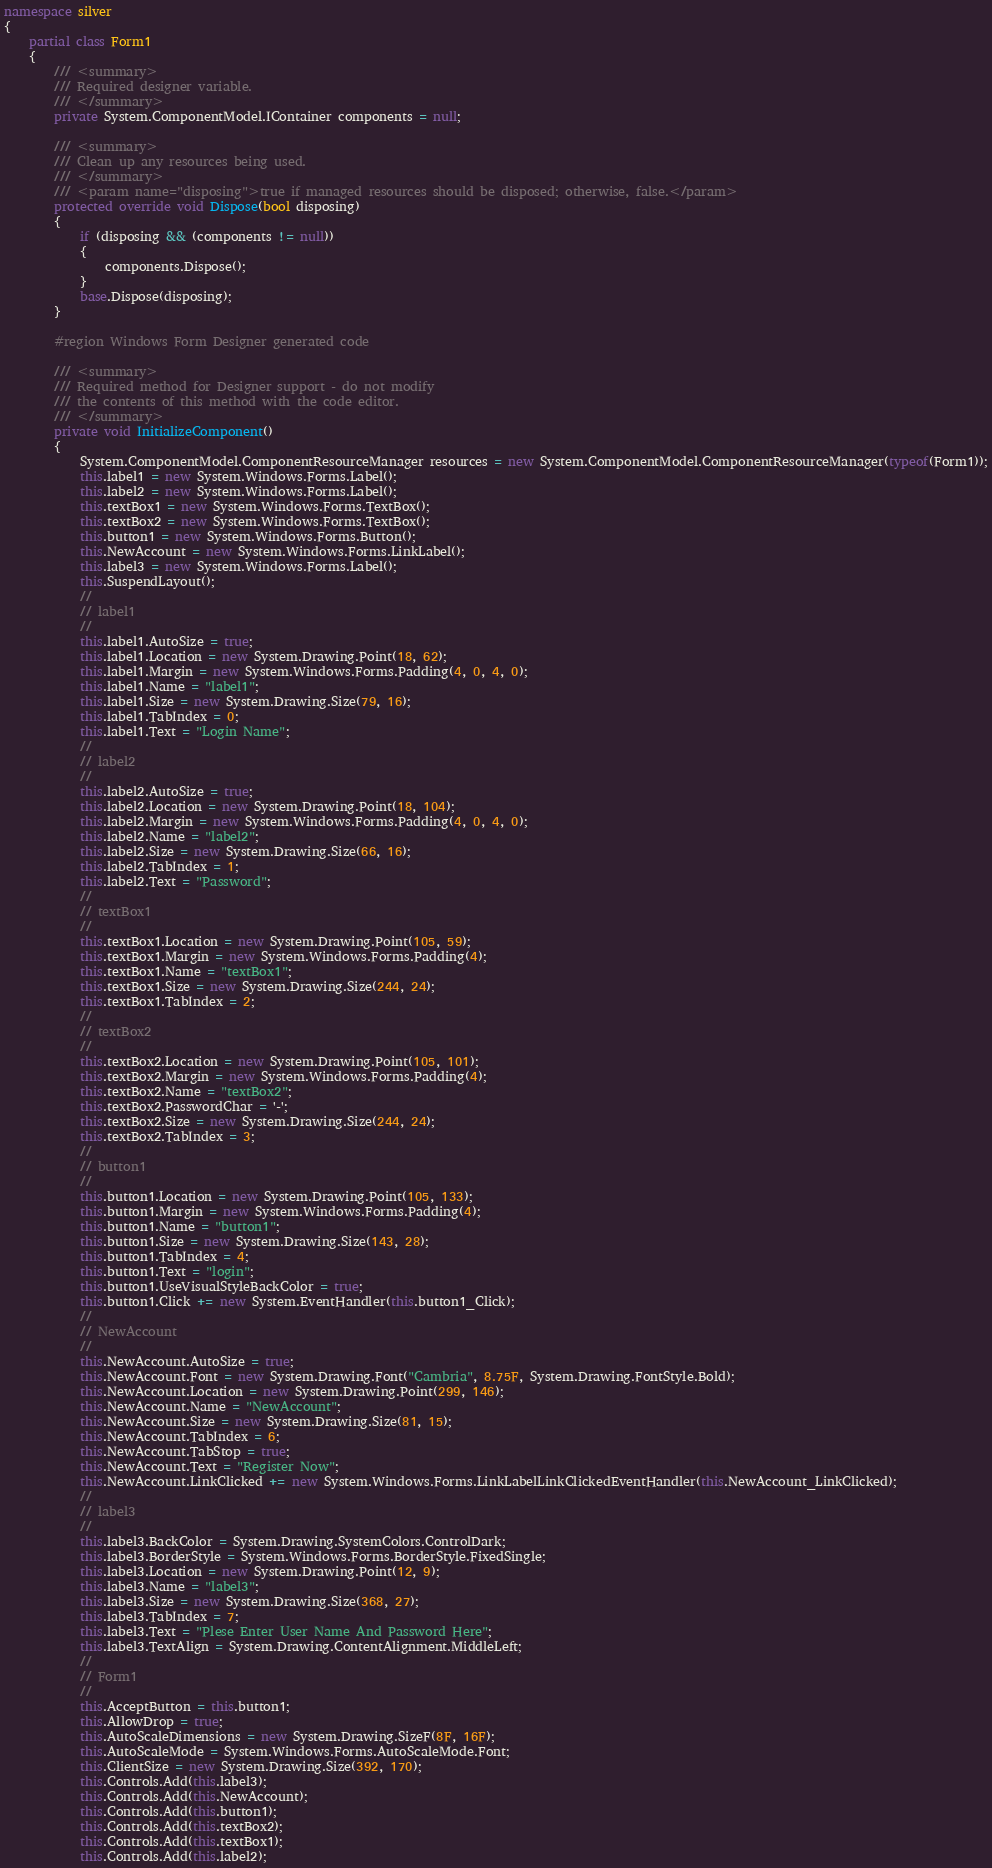<code> <loc_0><loc_0><loc_500><loc_500><_C#_>namespace silver
{
    partial class Form1
    {
        /// <summary>
        /// Required designer variable.
        /// </summary>
        private System.ComponentModel.IContainer components = null;

        /// <summary>
        /// Clean up any resources being used.
        /// </summary>
        /// <param name="disposing">true if managed resources should be disposed; otherwise, false.</param>
        protected override void Dispose(bool disposing)
        {
            if (disposing && (components != null))
            {
                components.Dispose();
            }
            base.Dispose(disposing);
        }

        #region Windows Form Designer generated code

        /// <summary>
        /// Required method for Designer support - do not modify
        /// the contents of this method with the code editor.
        /// </summary>
        private void InitializeComponent()
        {
            System.ComponentModel.ComponentResourceManager resources = new System.ComponentModel.ComponentResourceManager(typeof(Form1));
            this.label1 = new System.Windows.Forms.Label();
            this.label2 = new System.Windows.Forms.Label();
            this.textBox1 = new System.Windows.Forms.TextBox();
            this.textBox2 = new System.Windows.Forms.TextBox();
            this.button1 = new System.Windows.Forms.Button();
            this.NewAccount = new System.Windows.Forms.LinkLabel();
            this.label3 = new System.Windows.Forms.Label();
            this.SuspendLayout();
            // 
            // label1
            // 
            this.label1.AutoSize = true;
            this.label1.Location = new System.Drawing.Point(18, 62);
            this.label1.Margin = new System.Windows.Forms.Padding(4, 0, 4, 0);
            this.label1.Name = "label1";
            this.label1.Size = new System.Drawing.Size(79, 16);
            this.label1.TabIndex = 0;
            this.label1.Text = "Login Name";
            // 
            // label2
            // 
            this.label2.AutoSize = true;
            this.label2.Location = new System.Drawing.Point(18, 104);
            this.label2.Margin = new System.Windows.Forms.Padding(4, 0, 4, 0);
            this.label2.Name = "label2";
            this.label2.Size = new System.Drawing.Size(66, 16);
            this.label2.TabIndex = 1;
            this.label2.Text = "Password";
            // 
            // textBox1
            // 
            this.textBox1.Location = new System.Drawing.Point(105, 59);
            this.textBox1.Margin = new System.Windows.Forms.Padding(4);
            this.textBox1.Name = "textBox1";
            this.textBox1.Size = new System.Drawing.Size(244, 24);
            this.textBox1.TabIndex = 2;
            // 
            // textBox2
            // 
            this.textBox2.Location = new System.Drawing.Point(105, 101);
            this.textBox2.Margin = new System.Windows.Forms.Padding(4);
            this.textBox2.Name = "textBox2";
            this.textBox2.PasswordChar = '-';
            this.textBox2.Size = new System.Drawing.Size(244, 24);
            this.textBox2.TabIndex = 3;
            // 
            // button1
            // 
            this.button1.Location = new System.Drawing.Point(105, 133);
            this.button1.Margin = new System.Windows.Forms.Padding(4);
            this.button1.Name = "button1";
            this.button1.Size = new System.Drawing.Size(143, 28);
            this.button1.TabIndex = 4;
            this.button1.Text = "login";
            this.button1.UseVisualStyleBackColor = true;
            this.button1.Click += new System.EventHandler(this.button1_Click);
            // 
            // NewAccount
            // 
            this.NewAccount.AutoSize = true;
            this.NewAccount.Font = new System.Drawing.Font("Cambria", 8.75F, System.Drawing.FontStyle.Bold);
            this.NewAccount.Location = new System.Drawing.Point(299, 146);
            this.NewAccount.Name = "NewAccount";
            this.NewAccount.Size = new System.Drawing.Size(81, 15);
            this.NewAccount.TabIndex = 6;
            this.NewAccount.TabStop = true;
            this.NewAccount.Text = "Register Now";
            this.NewAccount.LinkClicked += new System.Windows.Forms.LinkLabelLinkClickedEventHandler(this.NewAccount_LinkClicked);
            // 
            // label3
            // 
            this.label3.BackColor = System.Drawing.SystemColors.ControlDark;
            this.label3.BorderStyle = System.Windows.Forms.BorderStyle.FixedSingle;
            this.label3.Location = new System.Drawing.Point(12, 9);
            this.label3.Name = "label3";
            this.label3.Size = new System.Drawing.Size(368, 27);
            this.label3.TabIndex = 7;
            this.label3.Text = "Plese Enter User Name And Password Here";
            this.label3.TextAlign = System.Drawing.ContentAlignment.MiddleLeft;
            // 
            // Form1
            // 
            this.AcceptButton = this.button1;
            this.AllowDrop = true;
            this.AutoScaleDimensions = new System.Drawing.SizeF(8F, 16F);
            this.AutoScaleMode = System.Windows.Forms.AutoScaleMode.Font;
            this.ClientSize = new System.Drawing.Size(392, 170);
            this.Controls.Add(this.label3);
            this.Controls.Add(this.NewAccount);
            this.Controls.Add(this.button1);
            this.Controls.Add(this.textBox2);
            this.Controls.Add(this.textBox1);
            this.Controls.Add(this.label2);</code> 